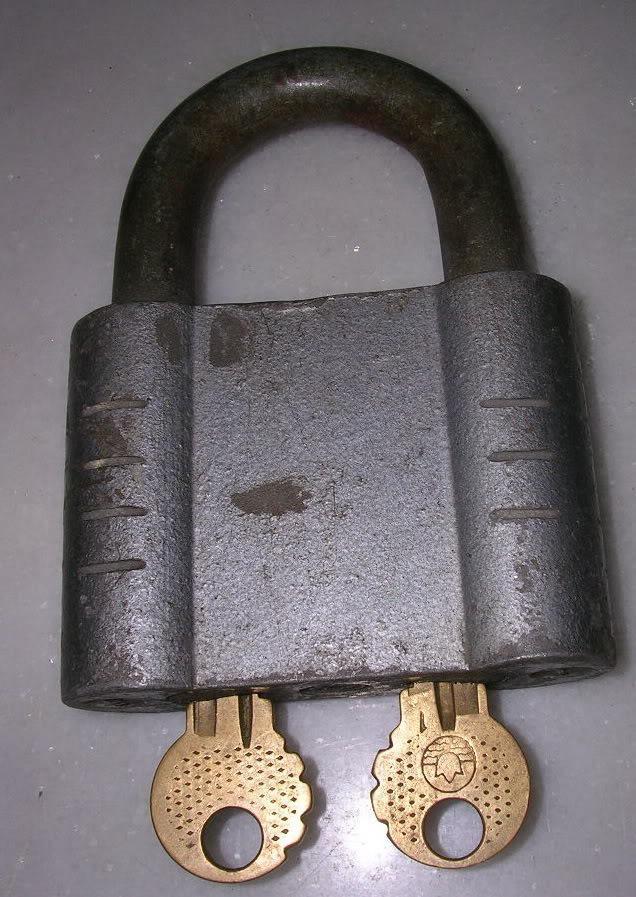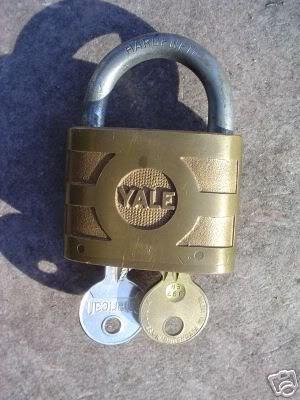The first image is the image on the left, the second image is the image on the right. Given the left and right images, does the statement "An image shows one key on a colored string to the left of a vintage lock." hold true? Answer yes or no. No. The first image is the image on the left, the second image is the image on the right. Evaluate the accuracy of this statement regarding the images: "Both locks are in the lock position.". Is it true? Answer yes or no. Yes. 